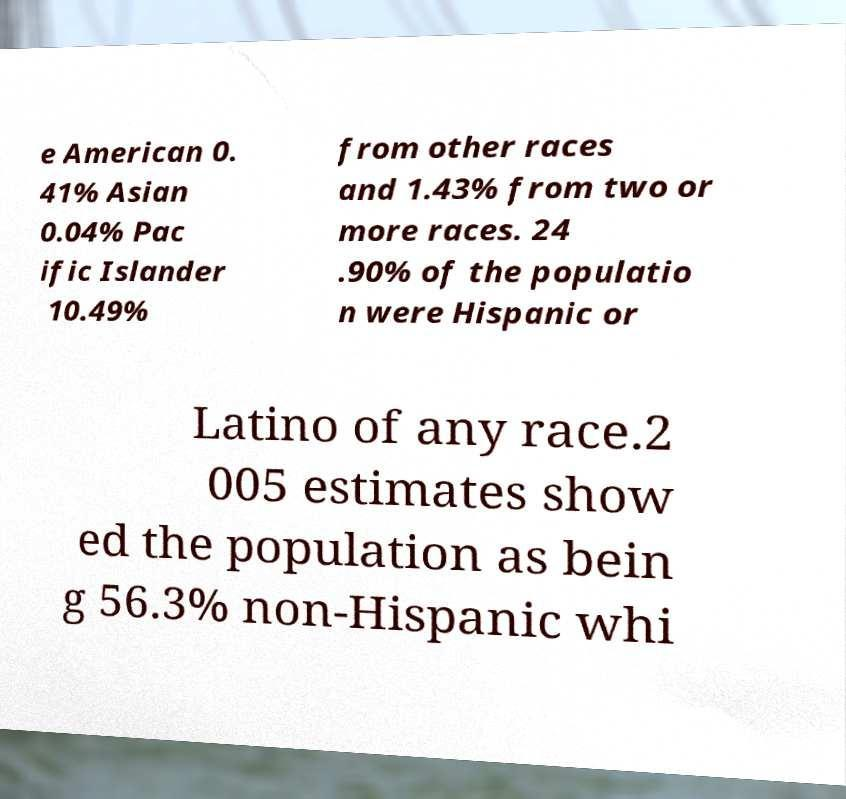For documentation purposes, I need the text within this image transcribed. Could you provide that? e American 0. 41% Asian 0.04% Pac ific Islander 10.49% from other races and 1.43% from two or more races. 24 .90% of the populatio n were Hispanic or Latino of any race.2 005 estimates show ed the population as bein g 56.3% non-Hispanic whi 